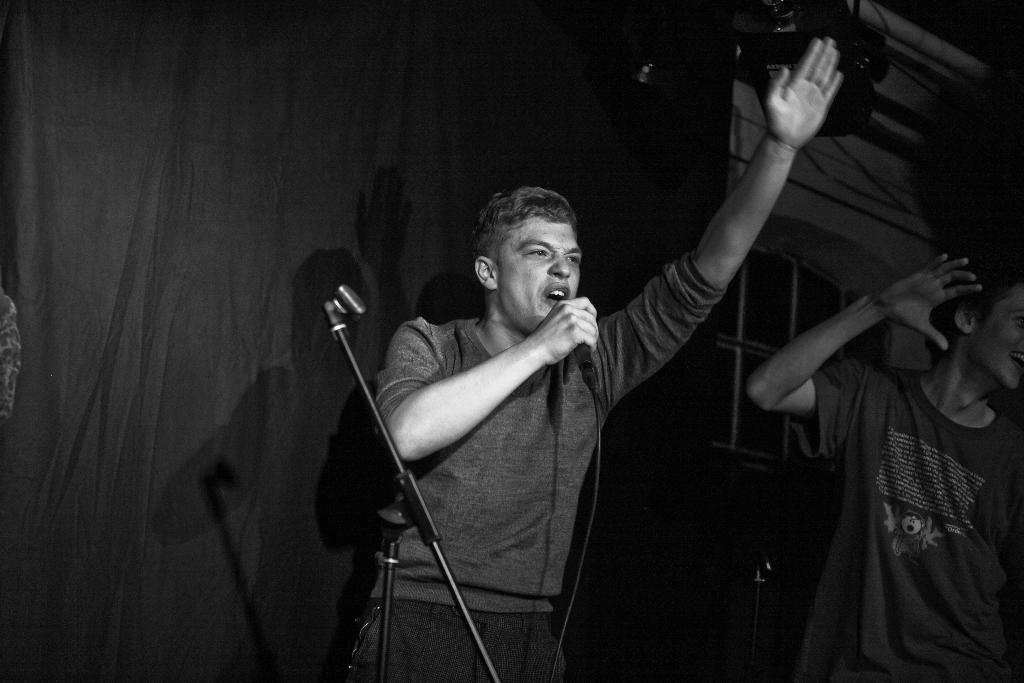What is the main activity of the person in the image? The person in the image is singing on a mic. Is there anyone else present in the image? Yes, there is another person beside the singer. Can you describe the background of the image? There is a cloth visible in the background. What type of grain is being harvested in the image? There is no grain or harvesting activity present in the image. Can you tell me the color of the vase on the stage? There is no vase present in the image. 